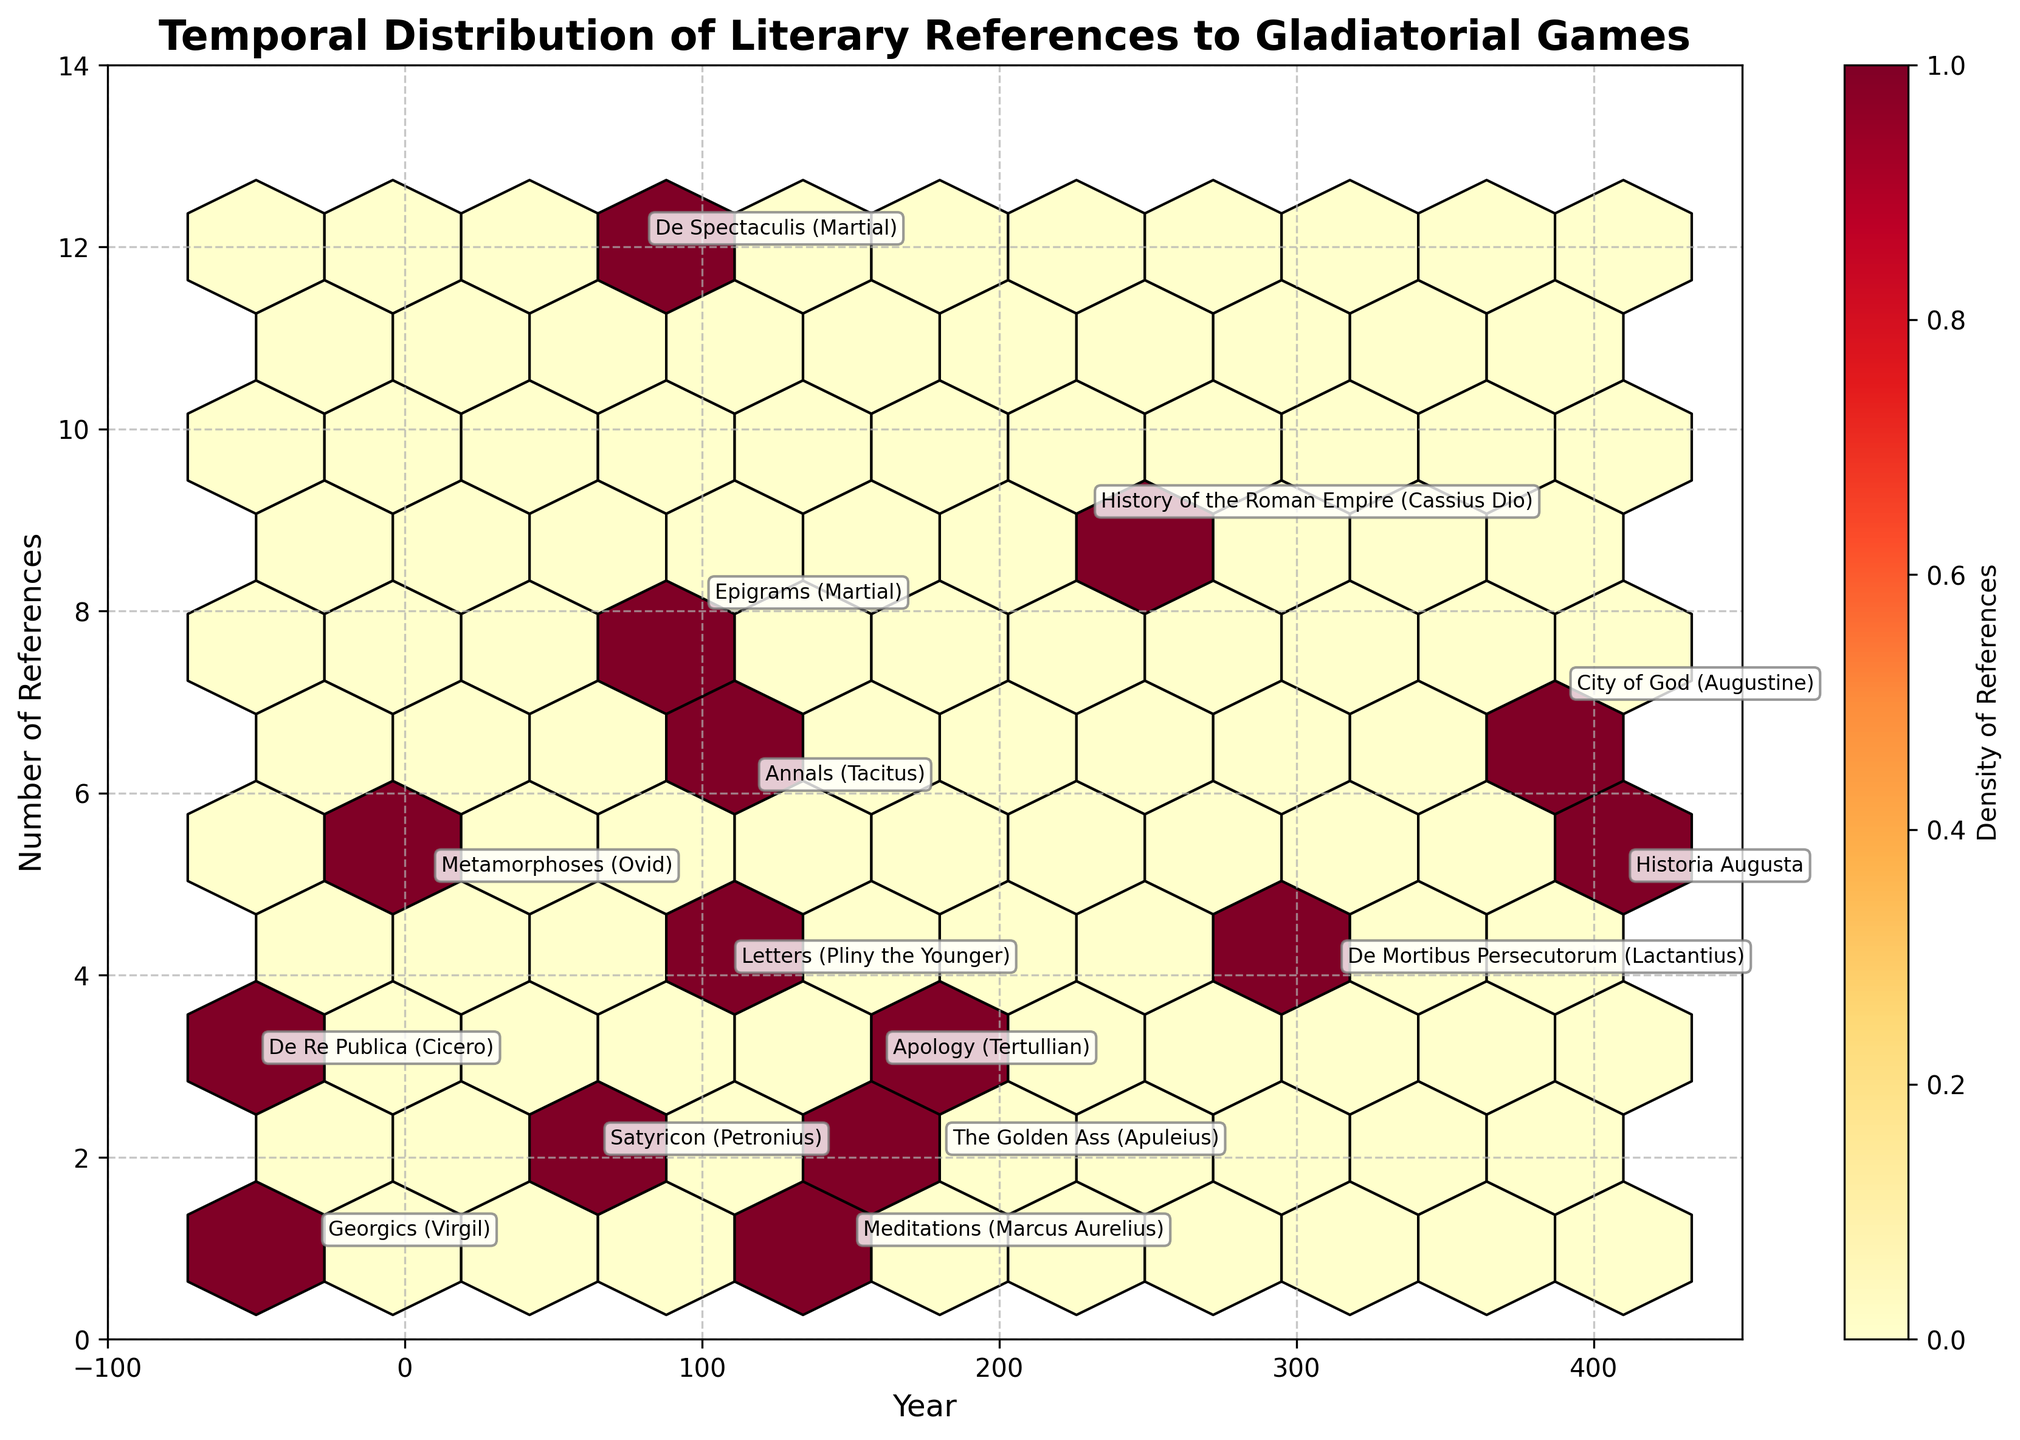What is the title of the plot? The title is usually found at the top of the plot. In this case, the title is written as 'Temporal Distribution of Literary References to Gladiatorial Games'.
Answer: Temporal Distribution of Literary References to Gladiatorial Games What do the x-axis and y-axis represent? The x-axis represents the 'Year', which stretches from -100 to 450. The y-axis represents the 'Number of References', which extends from 0 to slightly above 12.
Answer: Year and Number of References How many data points show more than 10 references? By looking at the y-axis and identifying the hexagons having references greater than 10, we see only one point around the year 80.
Answer: 1 Which year had the highest number of references, and what was the value? By examining the uppermost hexagon in the plot and noting the year annotation, we see that around the year 80, the text "De Spectaculis (Martial)" had 12 references, the highest in the dataset.
Answer: Year 80, 12 references Between which two periods is there the highest density of references? The density of references is indicated by the color of the hexagons. The most intense color appears around the period from approximately 0 to 200 AD.
Answer: 0 to 200 AD What is the average number of references made in the texts around 100 AD? The texts around 100 AD, specifically "Epigrams (Martial)" with 8 references and "Letters (Pliny the Younger)" with 4 references, give an average: (8 + 4) / 2 = 6.
Answer: 6 Which text from before the common era (BCE) had the most references? Observing the left side of the x-axis (before year 0), the text "De Re Publica (Cicero)" had the maximum references of 3.
Answer: De Re Publica (Cicero) Are there more references in texts before or after 200 AD? Summing the references before 200 AD, we get: 3 + 1 + 5 + 2 + 12 + 8 + 4 + 6 + 1 + 3 + 2 = 47. For after 200 AD: 9 + 4 + 7 + 5 = 25.
Answer: Before 200 AD How does the number of references shift from "Metamorphoses (Ovid)" to "Satyricon (Petronius)"? "Metamorphoses (Ovid)" had 5 references, while "Satyricon (Petronius)" shows 2 references, reflecting a decline of 3 references.
Answer: Declines by 3 What is the range of years covered in this plot? The earliest year visible is around -50, and the latest is around 410 AD. This gives a range of 460 years.
Answer: 460 years 